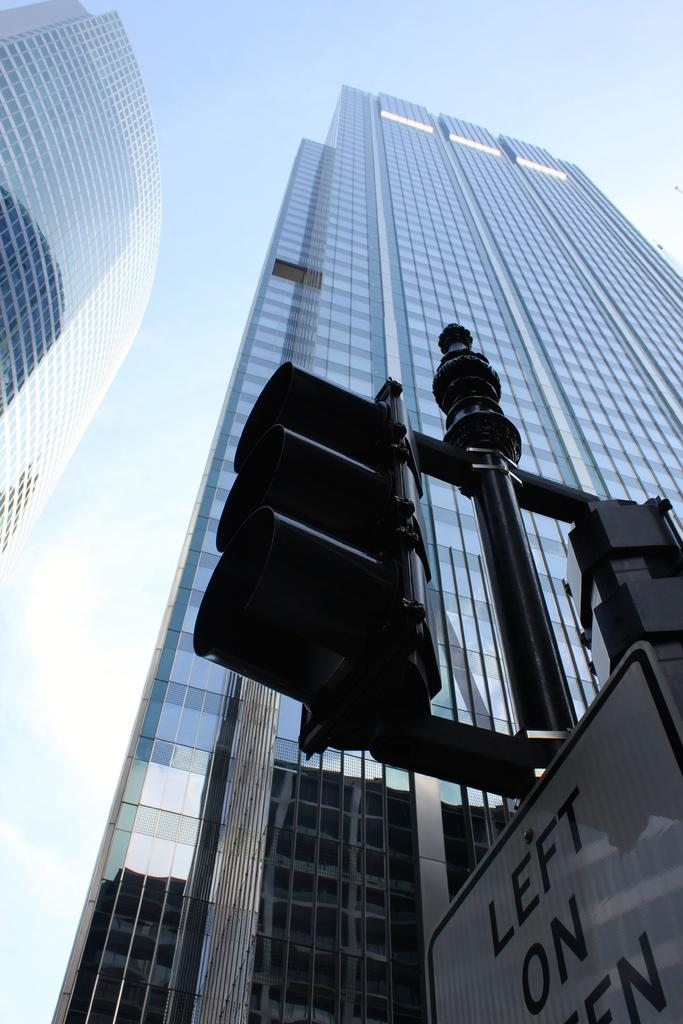How many buildings can be seen in the image? There are two buildings in the image. What is located on the right side of the image? There is a pole, a board, and traffic lights on the right side of the image. What is visible at the top of the image? The sky is visible at the top of the image. What color is the sock worn by the fireman in the image? There is no fireman or sock present in the image. What type of detail can be seen on the board in the image? The provided facts do not mention any specific details on the board, so we cannot answer this question definitively. 